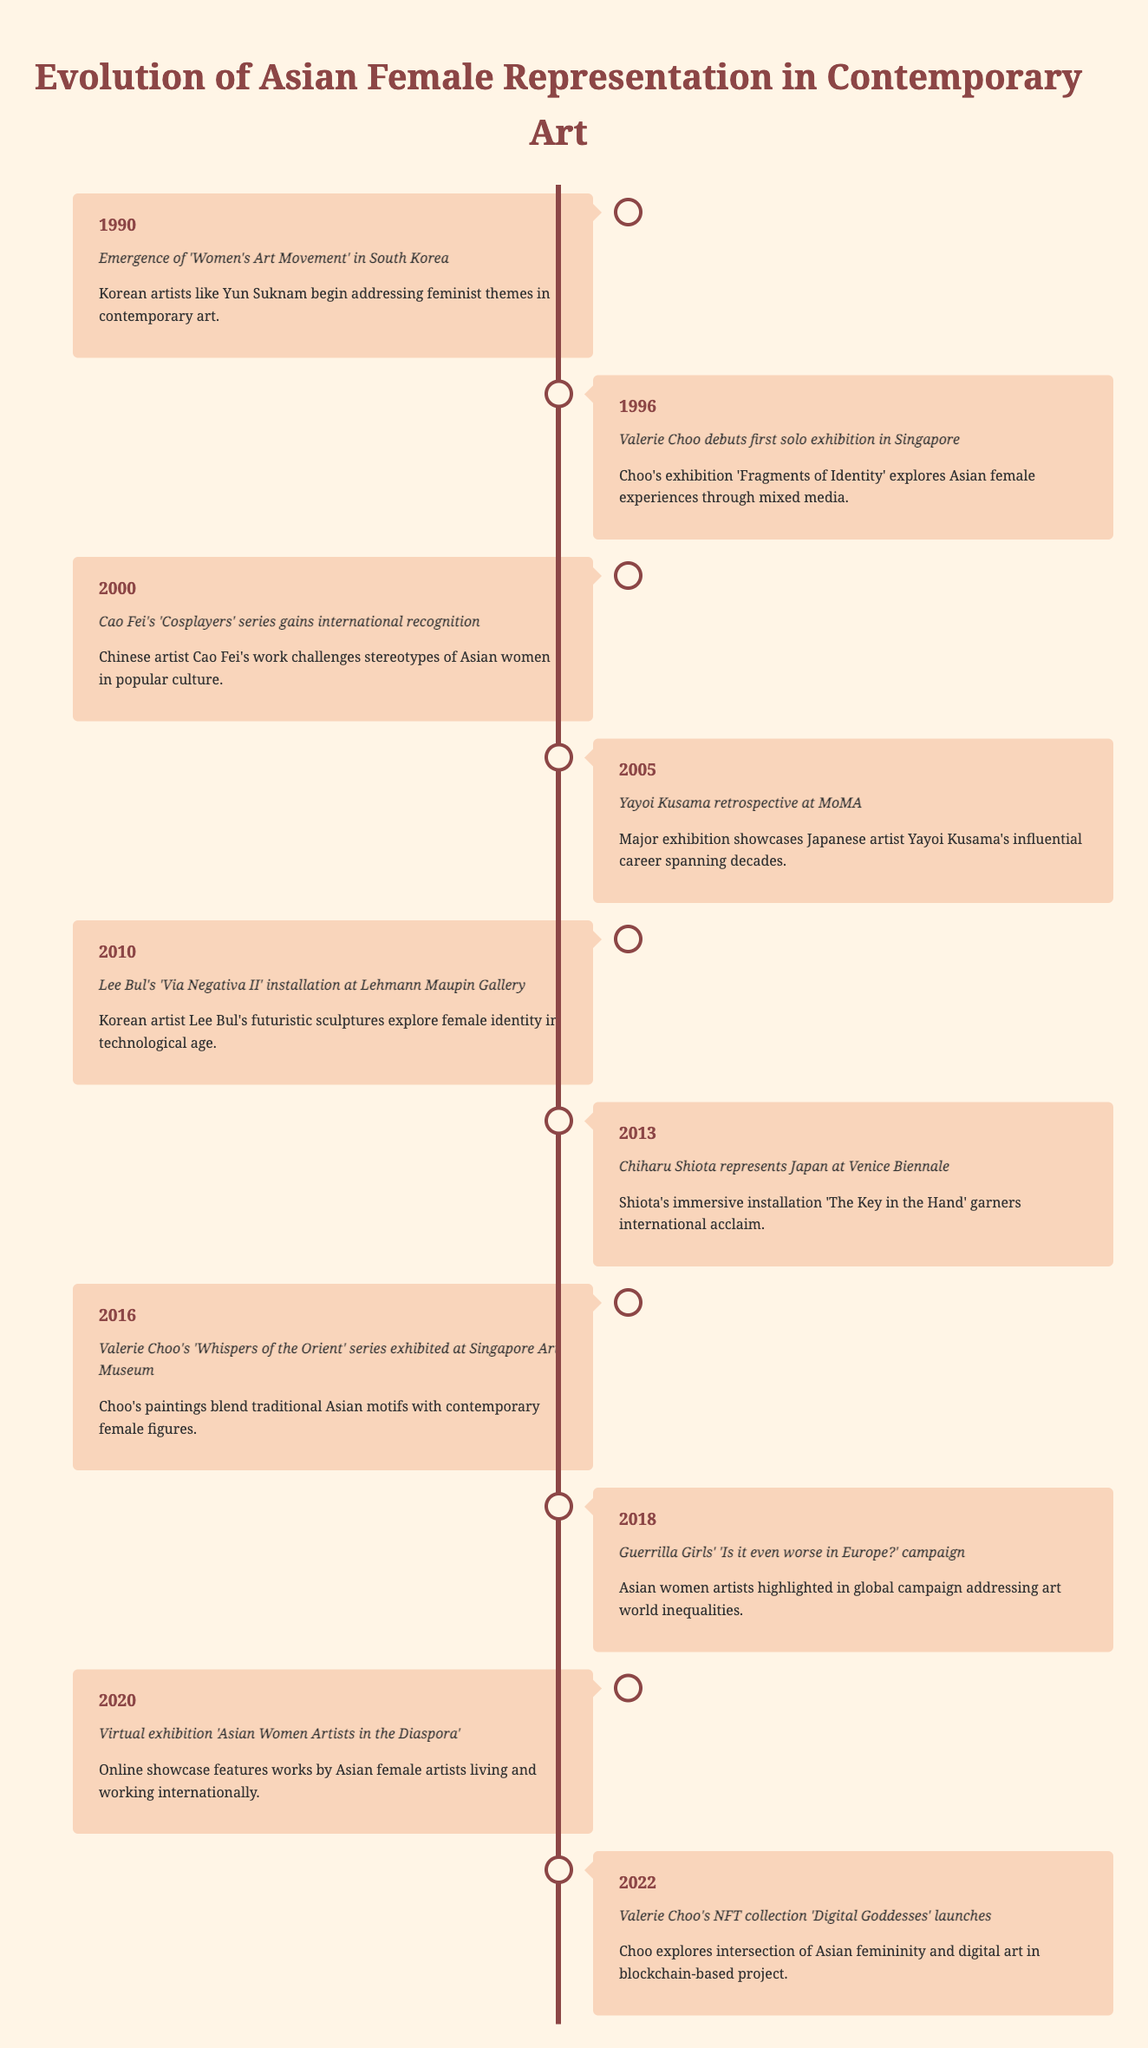What year did Valerie Choo debut her first solo exhibition in Singapore? The table indicates that Valerie Choo's first solo exhibition took place in 1996.
Answer: 1996 What event marked the beginning of the 'Women's Art Movement' in South Korea? According to the table, the event is the emergence of the 'Women's Art Movement' in South Korea in 1990, where Korean artists like Yun Suknam began addressing feminist themes.
Answer: Emergence of 'Women's Art Movement' in South Korea How many years are there between Lee Bul's installation and the launch of Valerie Choo's NFT collection? Lee Bul's installation occurred in 2010 and Choo's NFT collection launched in 2022. The difference is 2022 - 2010 = 12 years.
Answer: 12 years Which artist focused on Asian femininity in the digital art realm? Valerie Choo is the artist who focuses on Asian femininity in her NFT collection 'Digital Goddesses', as stated for the year 2022.
Answer: Valerie Choo In what year did Chiharu Shiota represent Japan at the Venice Biennale? The table states that Chiharu Shiota represented Japan at the Venice Biennale in 2013.
Answer: 2013 Was the 'Cosplayers' series by Cao Fei recognized internationally? Yes, the table confirms that Cao Fei's 'Cosplayers' series gained international recognition in 2000.
Answer: Yes How many events listed involve Valerie Choo? Valerie Choo is involved in three events: her debut solo exhibition in 1996, 'Whispers of the Orient' series in 2016, and the NFT collection in 2022. This totals 3 events.
Answer: 3 events What is the earliest event listed in the timeline? The earliest event recorded in the timeline is from 1990, regarding the 'Women's Art Movement' in South Korea.
Answer: 1990 How does the number of events after 2015 compare to those before? There are 5 events after 2015 (2016, 2018, 2020, 2022) and 5 events before (1990, 1996, 2000, 2005, 2010, 2013), so they are equal in number, which is a total of 5 for each.
Answer: Equal (5 each) 